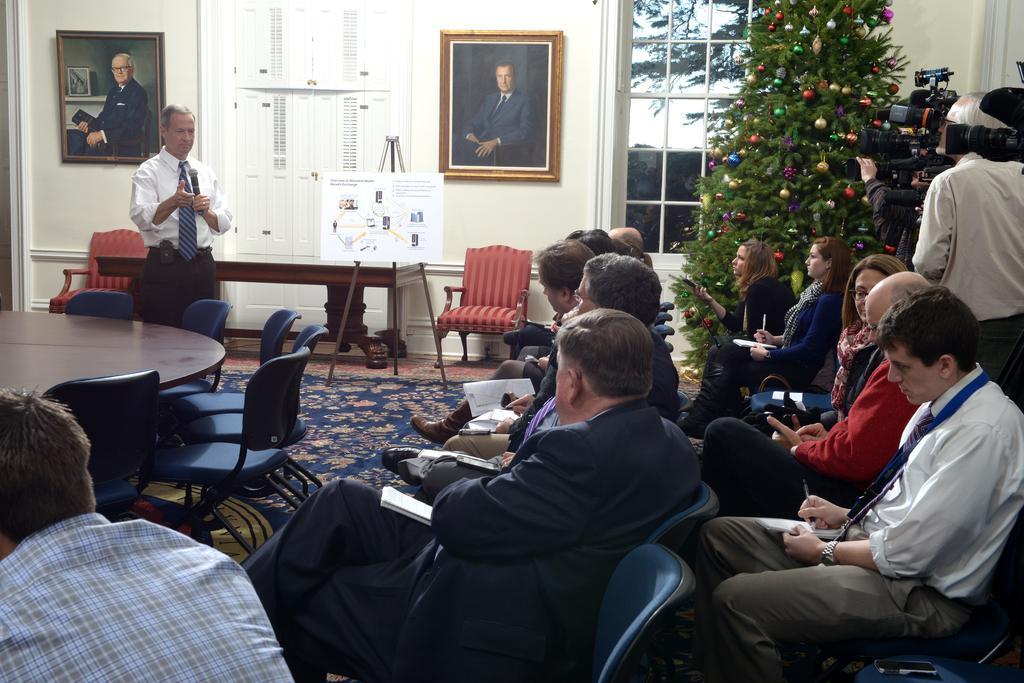Could you give a brief overview of what you see in this image? In this picture there are some people sitting in the chairs and writing something in their notepads. There is a guy Standing and speaking near the table. In the background, there is a board, chart and photo frame attached to the wall. We can observe a Christmas tree and window here. 